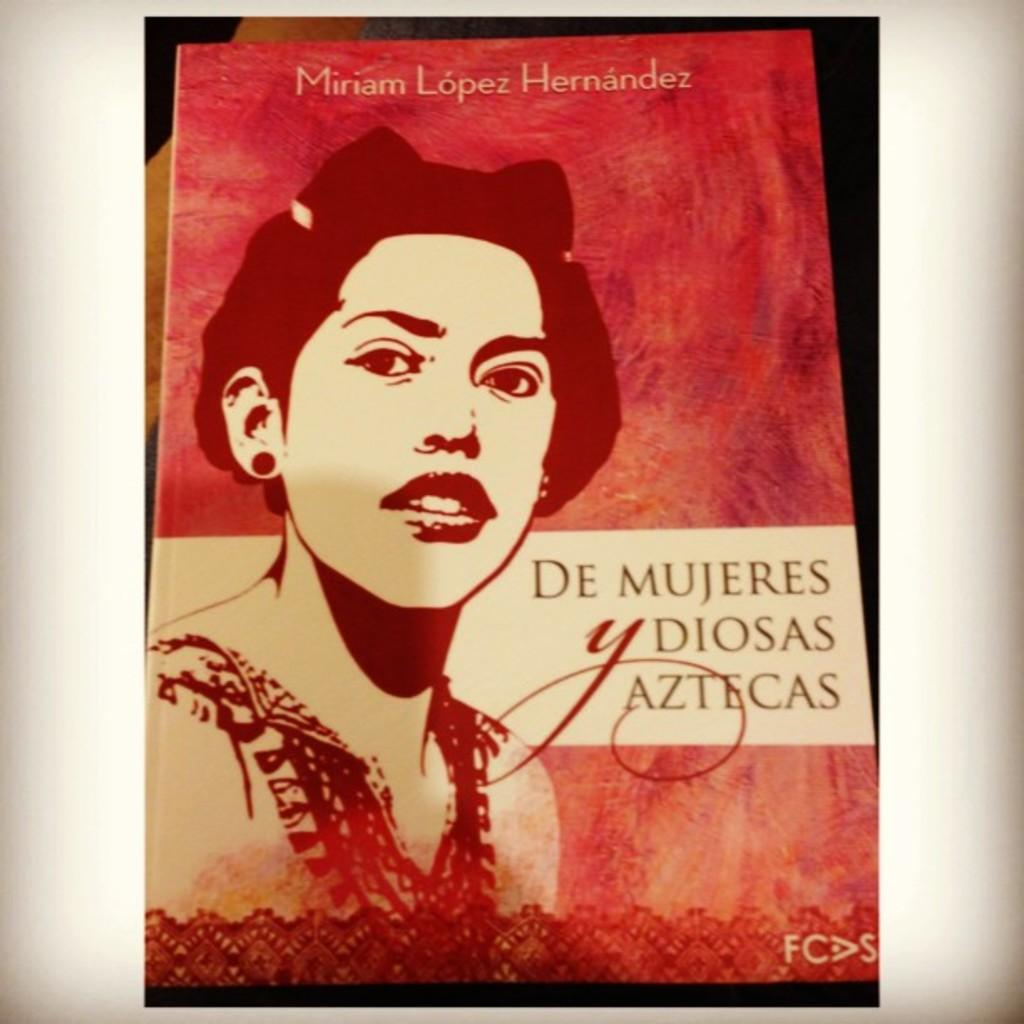What is the main subject of the image? There is a depiction of a person in the image. Are there any words or letters in the image? Yes, there is some text in the image. What color is the wrist of the person in the image? There is no information about the color of the person's wrist in the image, as it is not mentioned in the provided facts. 